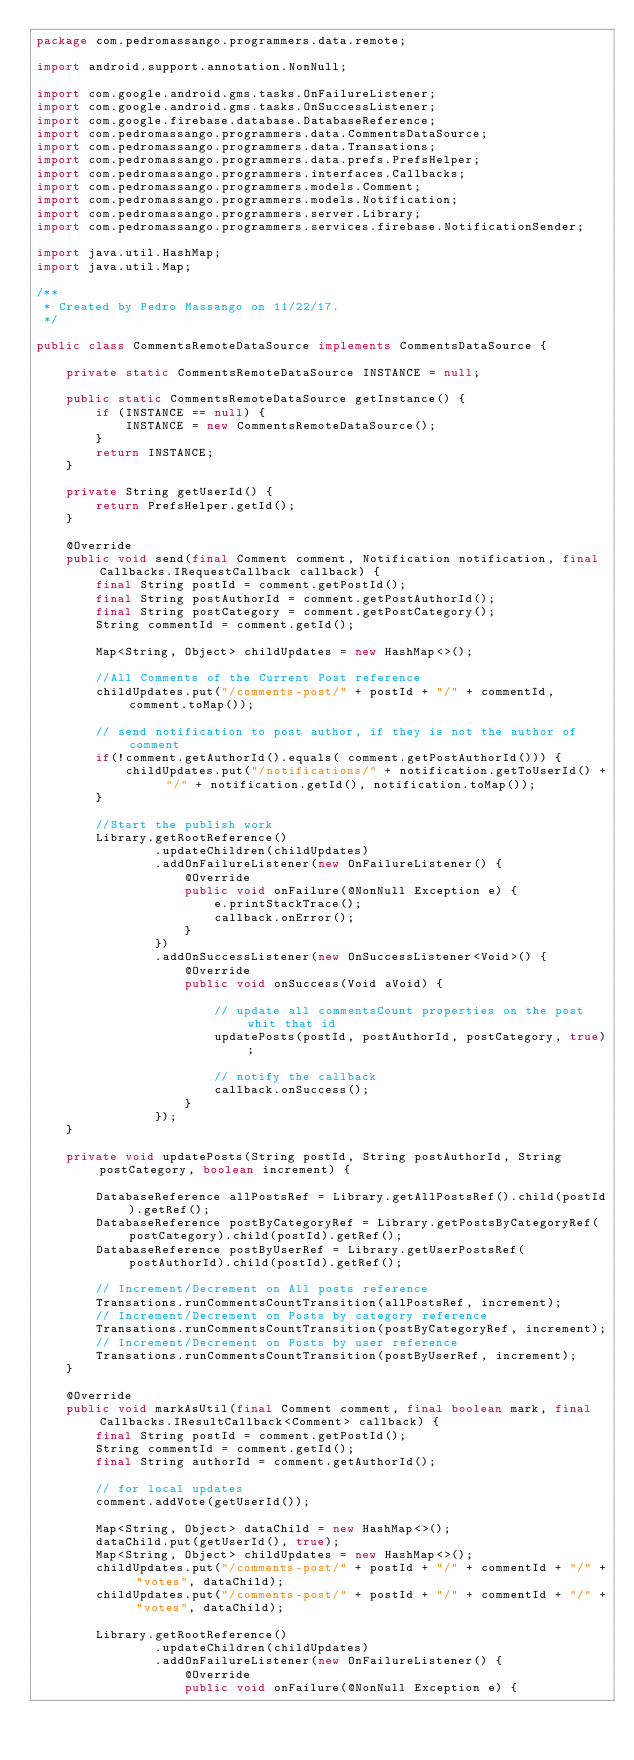<code> <loc_0><loc_0><loc_500><loc_500><_Java_>package com.pedromassango.programmers.data.remote;

import android.support.annotation.NonNull;

import com.google.android.gms.tasks.OnFailureListener;
import com.google.android.gms.tasks.OnSuccessListener;
import com.google.firebase.database.DatabaseReference;
import com.pedromassango.programmers.data.CommentsDataSource;
import com.pedromassango.programmers.data.Transations;
import com.pedromassango.programmers.data.prefs.PrefsHelper;
import com.pedromassango.programmers.interfaces.Callbacks;
import com.pedromassango.programmers.models.Comment;
import com.pedromassango.programmers.models.Notification;
import com.pedromassango.programmers.server.Library;
import com.pedromassango.programmers.services.firebase.NotificationSender;

import java.util.HashMap;
import java.util.Map;

/**
 * Created by Pedro Massango on 11/22/17.
 */

public class CommentsRemoteDataSource implements CommentsDataSource {

    private static CommentsRemoteDataSource INSTANCE = null;

    public static CommentsRemoteDataSource getInstance() {
        if (INSTANCE == null) {
            INSTANCE = new CommentsRemoteDataSource();
        }
        return INSTANCE;
    }

    private String getUserId() {
        return PrefsHelper.getId();
    }

    @Override
    public void send(final Comment comment, Notification notification, final Callbacks.IRequestCallback callback) {
        final String postId = comment.getPostId();
        final String postAuthorId = comment.getPostAuthorId();
        final String postCategory = comment.getPostCategory();
        String commentId = comment.getId();

        Map<String, Object> childUpdates = new HashMap<>();

        //All Comments of the Current Post reference
        childUpdates.put("/comments-post/" + postId + "/" + commentId, comment.toMap());

        // send notification to post author, if they is not the author of comment
        if(!comment.getAuthorId().equals( comment.getPostAuthorId())) {
            childUpdates.put("/notifications/" + notification.getToUserId() + "/" + notification.getId(), notification.toMap());
        }

        //Start the publish work
        Library.getRootReference()
                .updateChildren(childUpdates)
                .addOnFailureListener(new OnFailureListener() {
                    @Override
                    public void onFailure(@NonNull Exception e) {
                        e.printStackTrace();
                        callback.onError();
                    }
                })
                .addOnSuccessListener(new OnSuccessListener<Void>() {
                    @Override
                    public void onSuccess(Void aVoid) {

                        // update all commentsCount properties on the post whit that id
                        updatePosts(postId, postAuthorId, postCategory, true);

                        // notify the callback
                        callback.onSuccess();
                    }
                });
    }

    private void updatePosts(String postId, String postAuthorId, String postCategory, boolean increment) {

        DatabaseReference allPostsRef = Library.getAllPostsRef().child(postId).getRef();
        DatabaseReference postByCategoryRef = Library.getPostsByCategoryRef(postCategory).child(postId).getRef();
        DatabaseReference postByUserRef = Library.getUserPostsRef(postAuthorId).child(postId).getRef();

        // Increment/Decrement on All posts reference
        Transations.runCommentsCountTransition(allPostsRef, increment);
        // Increment/Decrement on Posts by category reference
        Transations.runCommentsCountTransition(postByCategoryRef, increment);
        // Increment/Decrement on Posts by user reference
        Transations.runCommentsCountTransition(postByUserRef, increment);
    }

    @Override
    public void markAsUtil(final Comment comment, final boolean mark, final Callbacks.IResultCallback<Comment> callback) {
        final String postId = comment.getPostId();
        String commentId = comment.getId();
        final String authorId = comment.getAuthorId();

        // for local updates
        comment.addVote(getUserId());

        Map<String, Object> dataChild = new HashMap<>();
        dataChild.put(getUserId(), true);
        Map<String, Object> childUpdates = new HashMap<>();
        childUpdates.put("/comments-post/" + postId + "/" + commentId + "/" + "votes", dataChild);
        childUpdates.put("/comments-post/" + postId + "/" + commentId + "/" + "votes", dataChild);

        Library.getRootReference()
                .updateChildren(childUpdates)
                .addOnFailureListener(new OnFailureListener() {
                    @Override
                    public void onFailure(@NonNull Exception e) {
</code> 